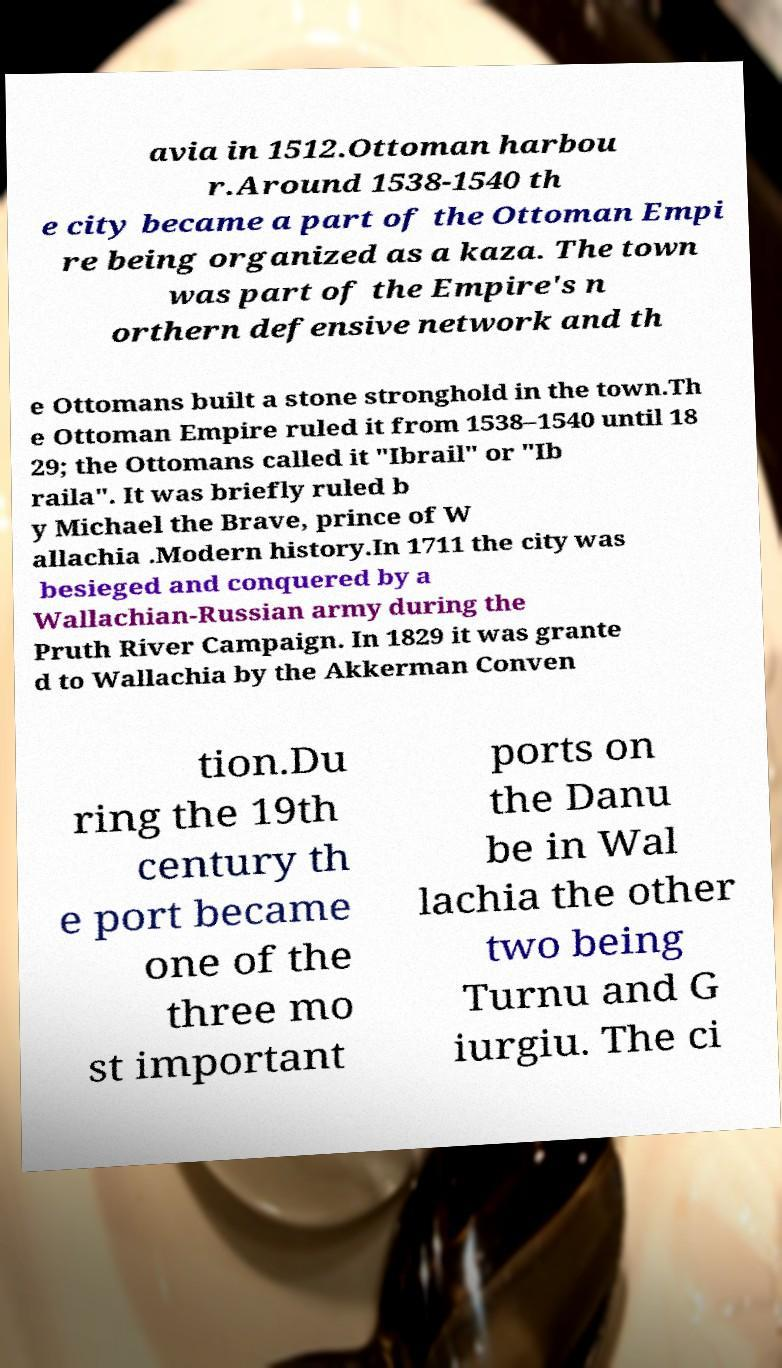Could you assist in decoding the text presented in this image and type it out clearly? avia in 1512.Ottoman harbou r.Around 1538-1540 th e city became a part of the Ottoman Empi re being organized as a kaza. The town was part of the Empire's n orthern defensive network and th e Ottomans built a stone stronghold in the town.Th e Ottoman Empire ruled it from 1538–1540 until 18 29; the Ottomans called it "Ibrail" or "Ib raila". It was briefly ruled b y Michael the Brave, prince of W allachia .Modern history.In 1711 the city was besieged and conquered by a Wallachian-Russian army during the Pruth River Campaign. In 1829 it was grante d to Wallachia by the Akkerman Conven tion.Du ring the 19th century th e port became one of the three mo st important ports on the Danu be in Wal lachia the other two being Turnu and G iurgiu. The ci 